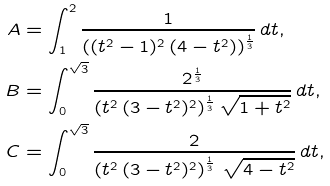<formula> <loc_0><loc_0><loc_500><loc_500>A & = \int ^ { 2 } _ { 1 } \frac { 1 } { ( ( t ^ { 2 } - 1 ) ^ { 2 } \, ( 4 - t ^ { 2 } ) ) ^ { \frac { 1 } { 3 } } } \, d t , \\ B & = \int ^ { \sqrt { 3 } } _ { 0 } \frac { 2 ^ { \frac { 1 } { 3 } } } { ( t ^ { 2 } \, ( 3 - t ^ { 2 } ) ^ { 2 } ) ^ { \frac { 1 } { 3 } } \, \sqrt { 1 + t ^ { 2 } } } \, d t , \\ C & = \int ^ { \sqrt { 3 } } _ { 0 } \frac { 2 } { \left ( t ^ { 2 } \, ( 3 - t ^ { 2 } ) ^ { 2 } \right ) ^ { \frac { 1 } { 3 } } \, \sqrt { 4 - t ^ { 2 } } } \, d t ,</formula> 